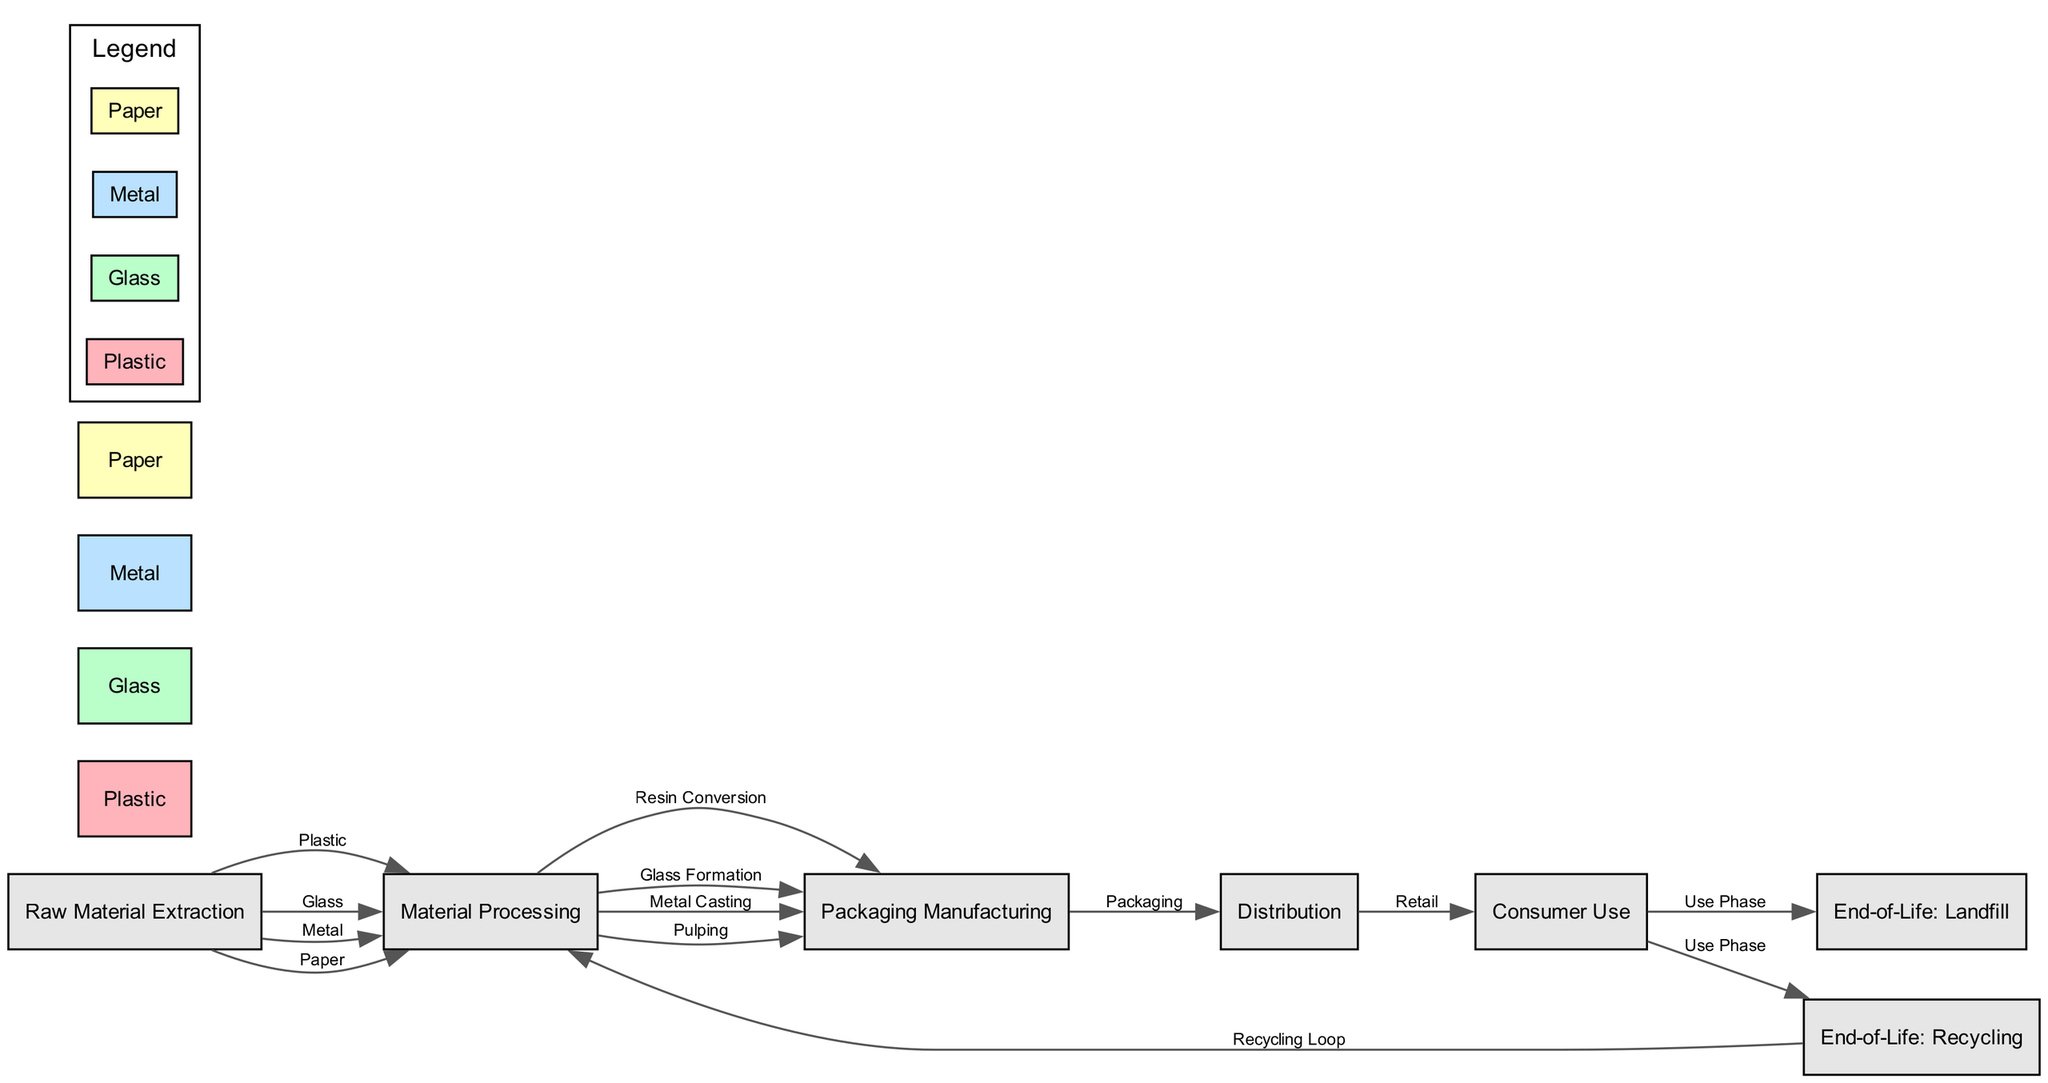What are the four types of material extracted in the food chain? The diagram shows four types of material connected to the "Raw Material Extraction" node: Plastic, Glass, Metal, and Paper. These materials represent the different packaging types being analyzed in terms of waste.
Answer: Plastic, Glass, Metal, Paper How many nodes represent packaging materials in the diagram? The diagram includes four nodes that specifically represent packaging materials: Plastic, Glass, Metal, and Paper. These materials are part of the various processes in the food chain and indicate their waste treatment.
Answer: Four Which material goes through the "Packaging Manufacturing" node? The "Packaging Manufacturing" node is connected to the edges from the "Material Processing" node, and it pertains to the processes involved in creating packaging from the extracted materials: Plastic, Glass, Metal, and Paper.
Answer: All materials What is the end-of-life option for materials after consumer use? In the diagram, the two end-of-life options for materials after "Consumer Use" are Recycling and Landfill, shown as branches indicating where waste materials go post-consumption.
Answer: Recycling and Landfill Which material re-enters the process through the recycling loop? The diagram shows a "Recycling Loop" where materials can cycle back into "Material Processing." This indicates a circle for the materials that can be recycled, emphasizing sustainable practices.
Answer: All materials How many edges connect "Material Processing" and "Packaging Manufacturing"? From the diagram, there are four edges connecting the "Material Processing" node to the "Packaging Manufacturing" node, representing the different conversion processes of each material into packaging.
Answer: Four What does the edge labeled 'Use Phase' connect to? The edge labeled 'Use Phase' connects the "Consumer Use" node to two endpoints: "End-of-Life: Recycling" and "End-of-Life: Landfill," illustrating the disposal pathways available for packaging after use.
Answer: Recycling and Landfill Which type of packaging material has the first step in the food chain? The first step in the food chain represents the initiation of material extraction. All types of packaging materials — Plastic, Glass, Metal, and Paper — start their lifecycle from this step, showcasing that they are all generated from raw materials.
Answer: All packaging materials 